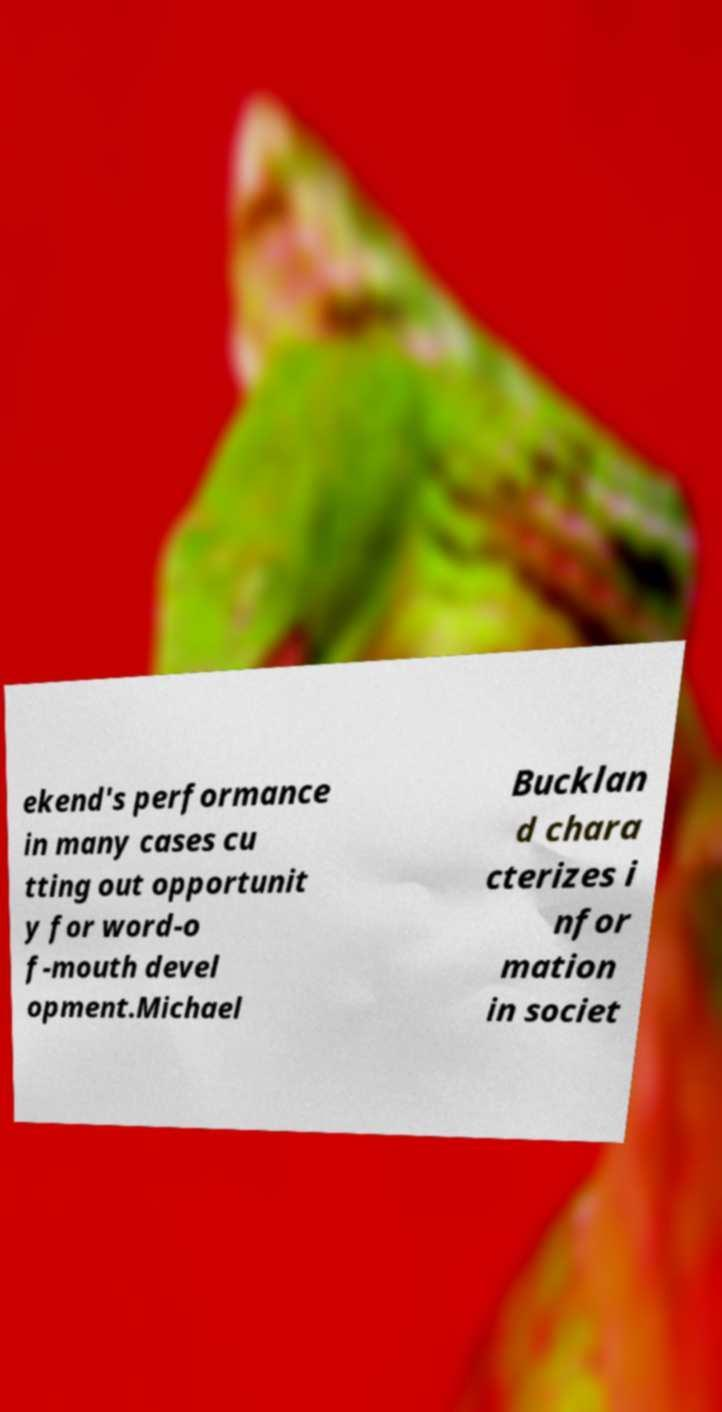Please read and relay the text visible in this image. What does it say? ekend's performance in many cases cu tting out opportunit y for word-o f-mouth devel opment.Michael Bucklan d chara cterizes i nfor mation in societ 